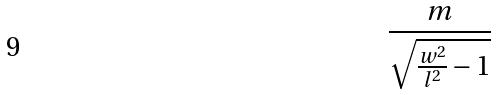<formula> <loc_0><loc_0><loc_500><loc_500>\frac { m } { \sqrt { \frac { w ^ { 2 } } { l ^ { 2 } } - 1 } }</formula> 